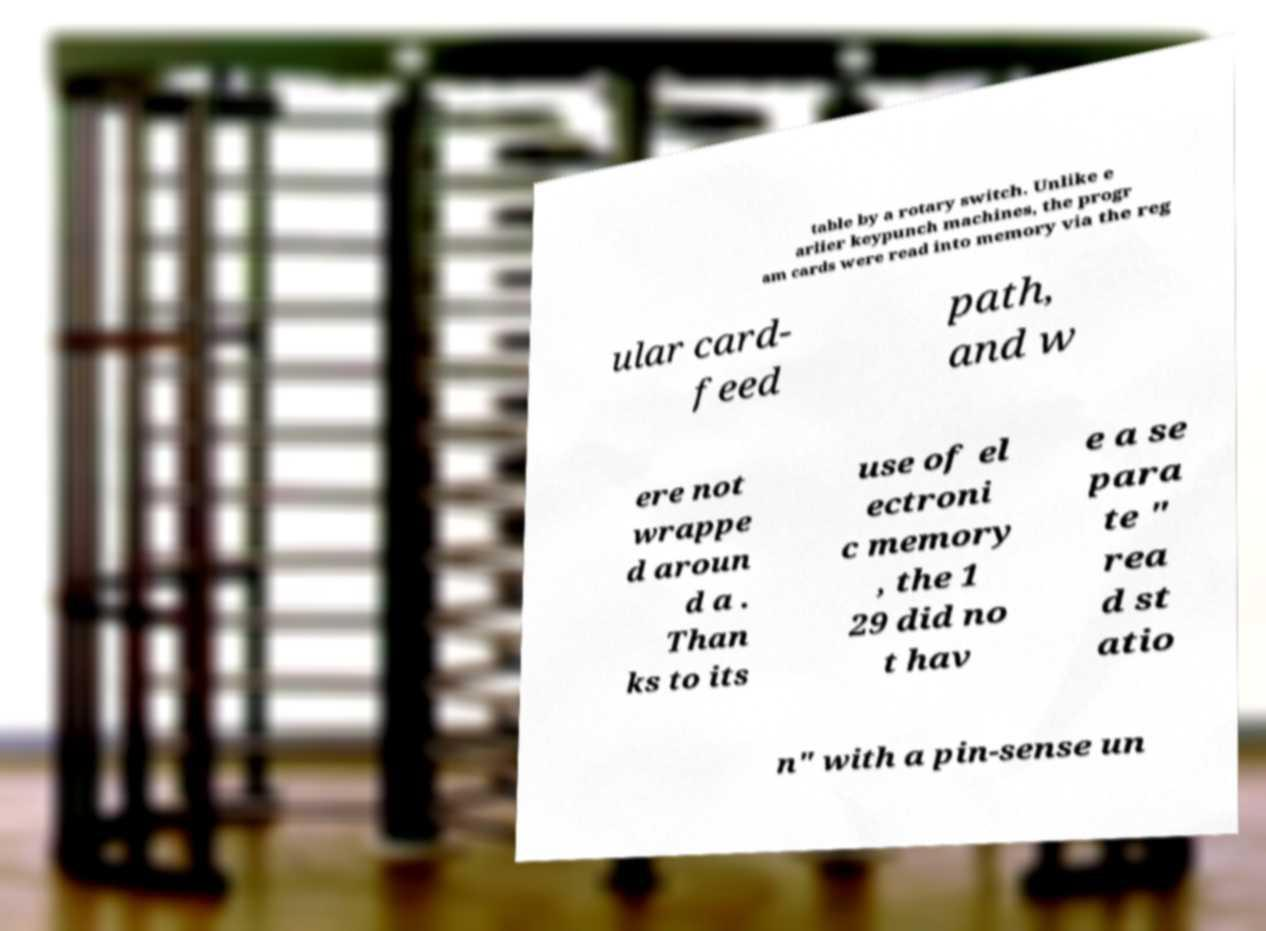For documentation purposes, I need the text within this image transcribed. Could you provide that? table by a rotary switch. Unlike e arlier keypunch machines, the progr am cards were read into memory via the reg ular card- feed path, and w ere not wrappe d aroun d a . Than ks to its use of el ectroni c memory , the 1 29 did no t hav e a se para te " rea d st atio n" with a pin-sense un 